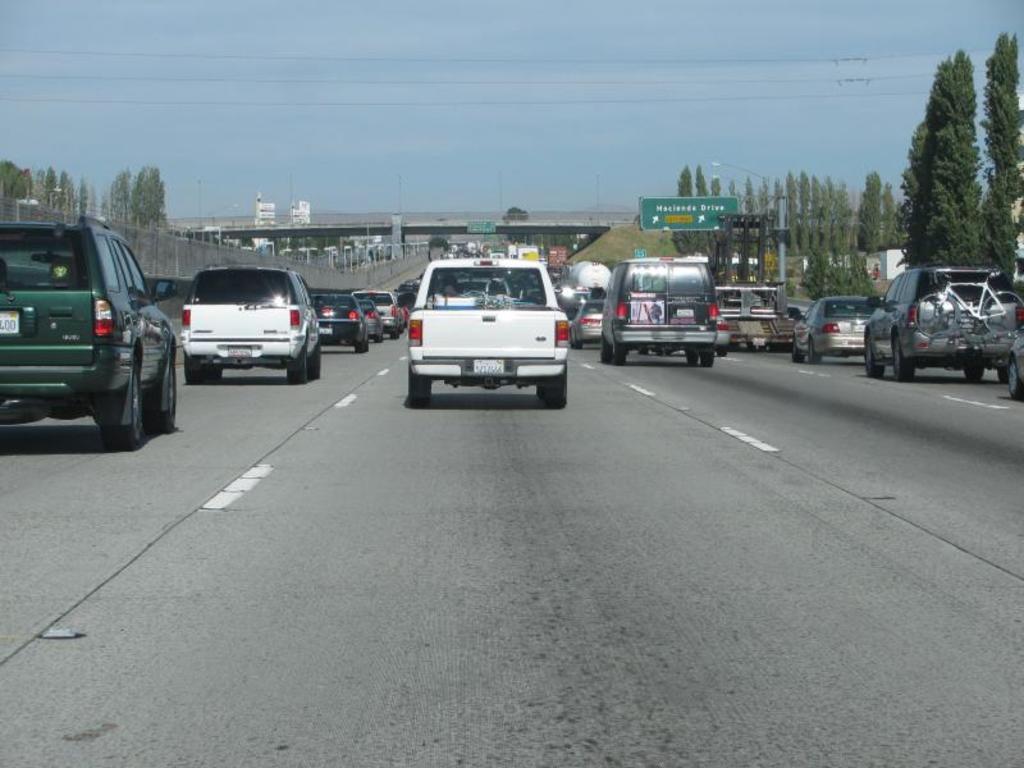How would you summarize this image in a sentence or two? Here we can see cars on the road. Background we can see boards,lights,poles,bridge,wires,trees and sky. 